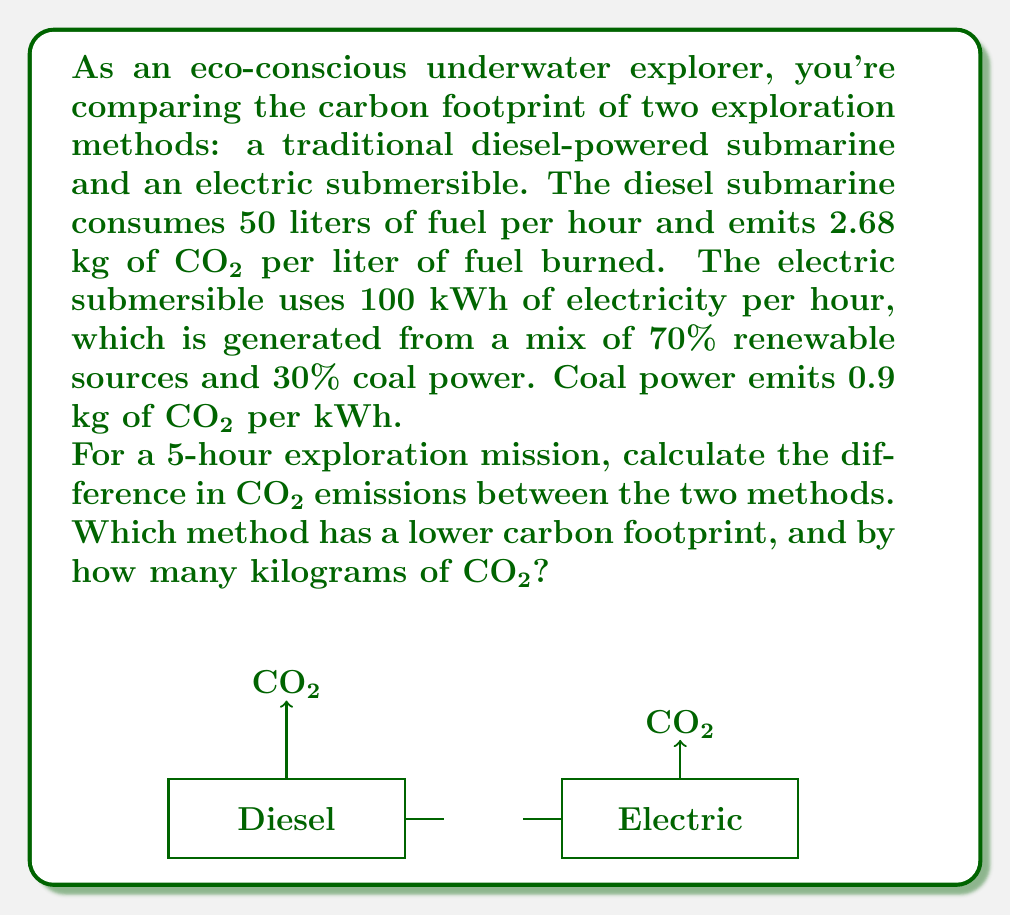Give your solution to this math problem. Let's solve this problem step-by-step:

1. Calculate CO₂ emissions for the diesel submarine:
   - Fuel consumption: 50 liters/hour × 5 hours = 250 liters
   - CO₂ emissions: 250 liters × 2.68 kg CO₂/liter = 670 kg CO₂

2. Calculate CO₂ emissions for the electric submersible:
   - Electricity consumption: 100 kWh/hour × 5 hours = 500 kWh
   - CO₂ emissions from coal power:
     500 kWh × 30% coal × 0.9 kg CO₂/kWh = 135 kg CO₂
   - CO₂ emissions from renewable sources: 0 kg (assumed)
   - Total CO₂ emissions: 135 kg CO₂

3. Calculate the difference in CO₂ emissions:
   $$\text{Difference} = \text{Diesel emissions} - \text{Electric emissions}$$
   $$\text{Difference} = 670 \text{ kg} - 135 \text{ kg} = 535 \text{ kg CO₂}$$

4. Determine which method has a lower carbon footprint:
   The electric submersible has lower emissions (135 kg CO₂ < 670 kg CO₂)

5. Calculate how much lower the carbon footprint is:
   535 kg CO₂ lower for the electric submersible
Answer: The electric submersible has a 535 kg CO₂ lower carbon footprint. 